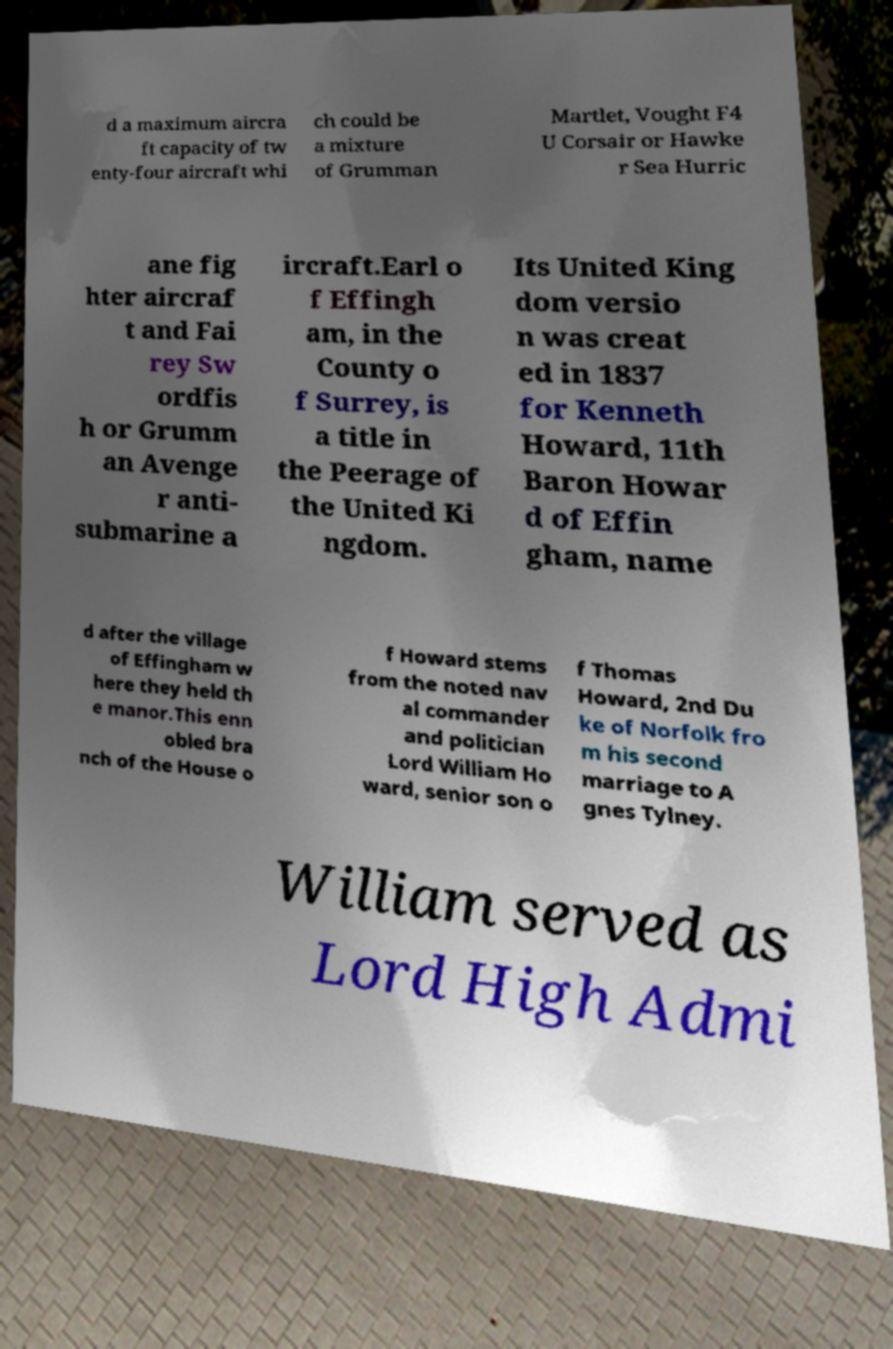Please identify and transcribe the text found in this image. d a maximum aircra ft capacity of tw enty-four aircraft whi ch could be a mixture of Grumman Martlet, Vought F4 U Corsair or Hawke r Sea Hurric ane fig hter aircraf t and Fai rey Sw ordfis h or Grumm an Avenge r anti- submarine a ircraft.Earl o f Effingh am, in the County o f Surrey, is a title in the Peerage of the United Ki ngdom. Its United King dom versio n was creat ed in 1837 for Kenneth Howard, 11th Baron Howar d of Effin gham, name d after the village of Effingham w here they held th e manor.This enn obled bra nch of the House o f Howard stems from the noted nav al commander and politician Lord William Ho ward, senior son o f Thomas Howard, 2nd Du ke of Norfolk fro m his second marriage to A gnes Tylney. William served as Lord High Admi 